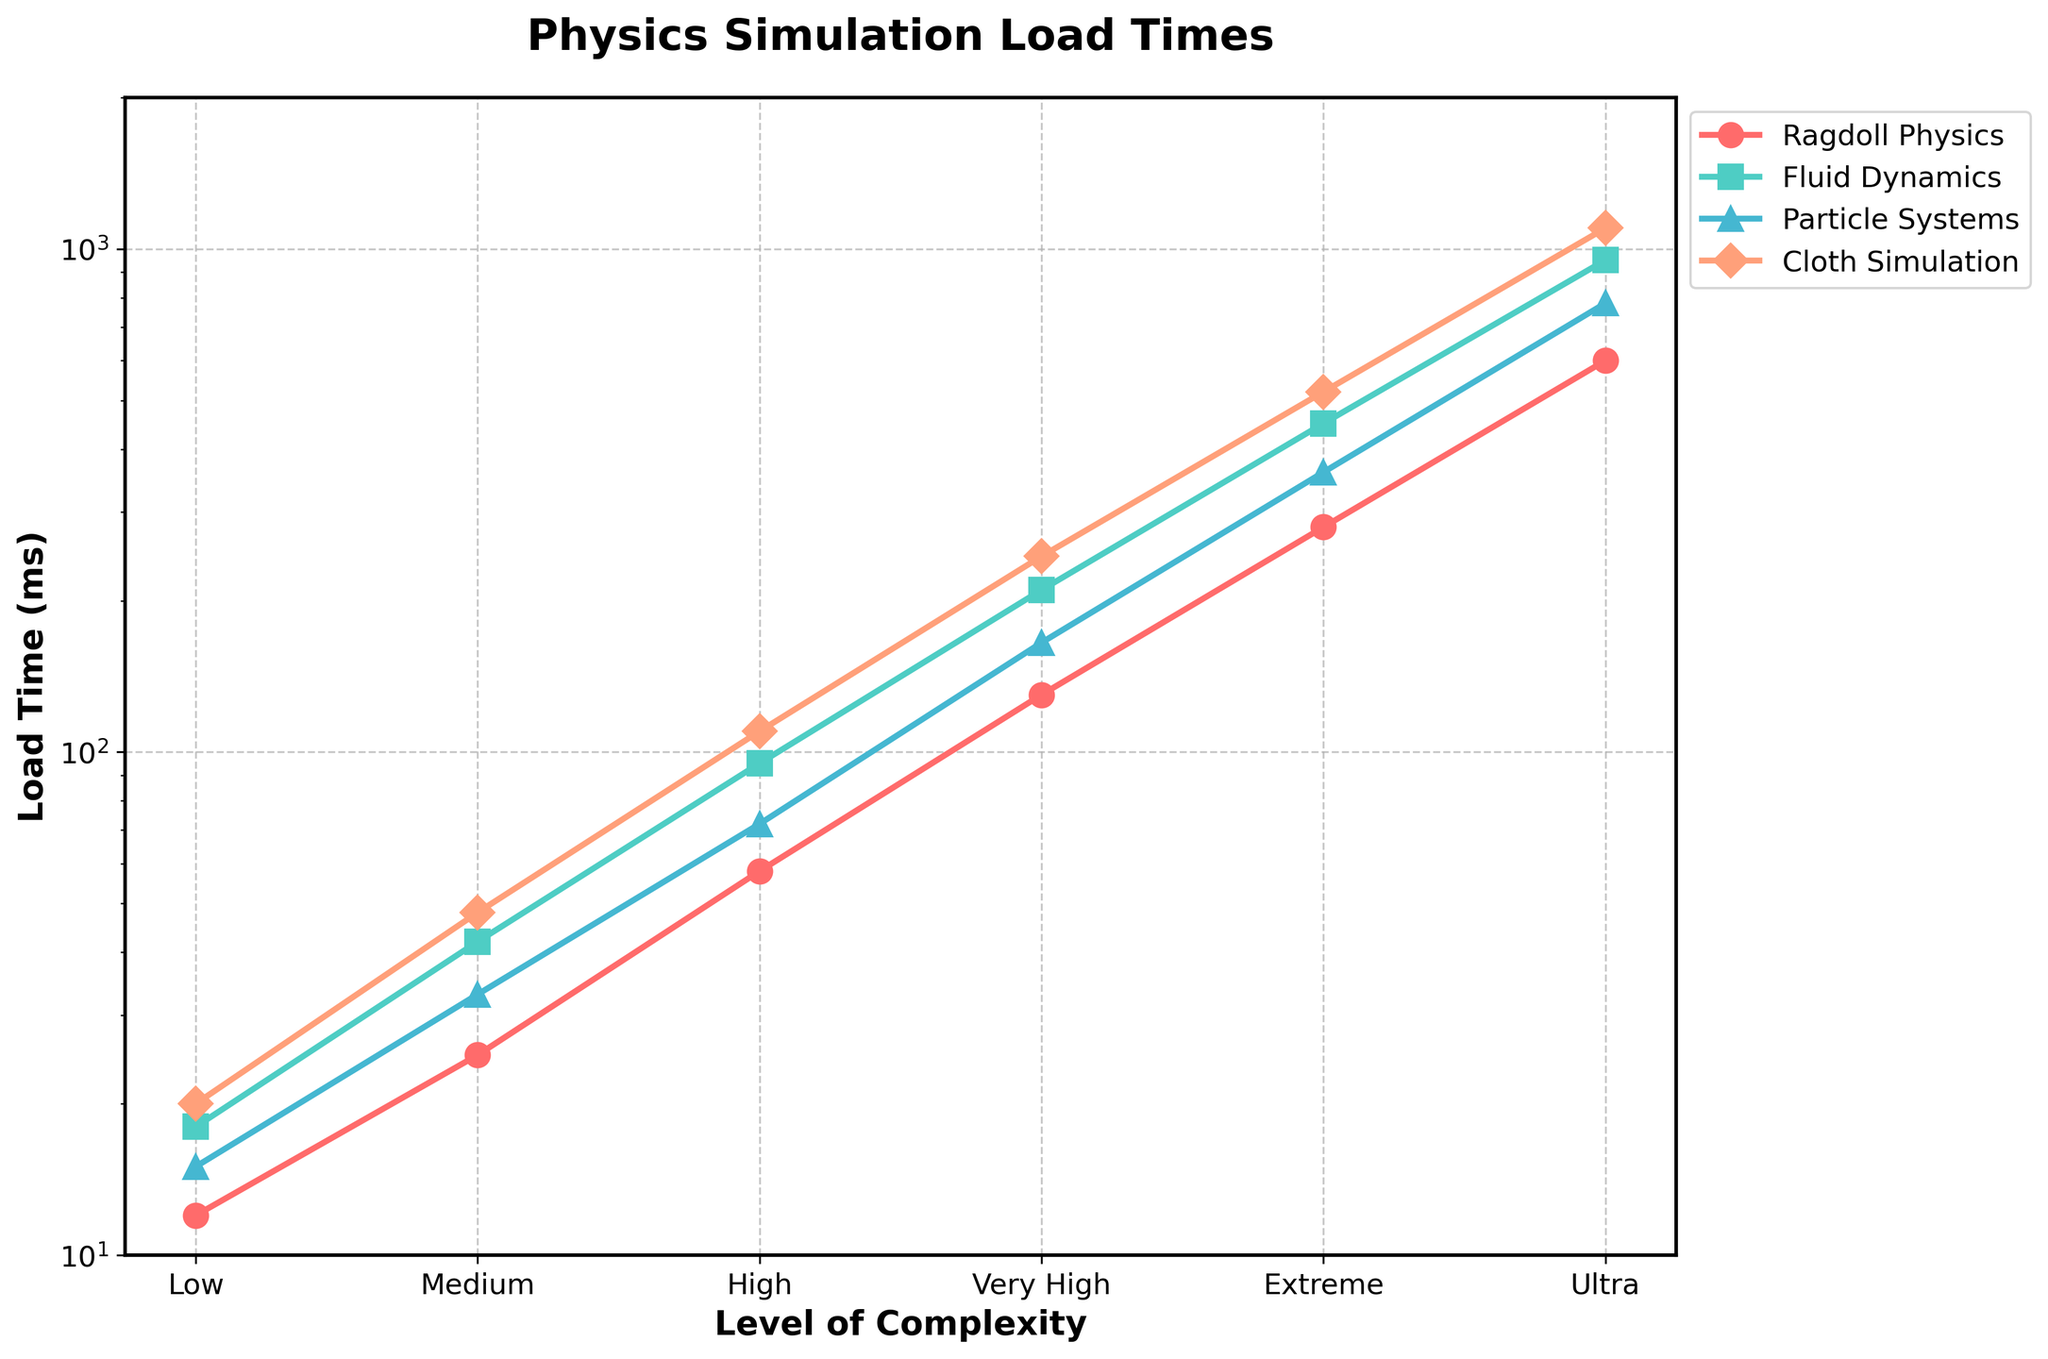What is the load time for Fluid Dynamics at the High complexity level? Look for the data point where Fluid Dynamics intersects with High complexity. Fluid Dynamics at High complexity is marked by a green line with triangle markers. The value reads 95 ms.
Answer: 95 ms How many times greater is the load time for Ragdoll Physics at Ultra complexity compared to Medium complexity? Identify the load times for Ragdoll Physics at Ultra and Medium complexity levels, which are represented by the red line with circle markers. From the plot, Medium complexity has a load time of 25 ms, and Ultra complexity has a load time of 600 ms. Calculate the ratio: 600 ms / 25 ms = 24.
Answer: 24 Which simulation has the highest load time at Very High complexity? Examine the data point at the Very High complexity level for all simulation types. Identify which peak is the highest. The pink line with diamond markers for Cloth Simulation records the highest load time at 245 ms.
Answer: Cloth Simulation What is the difference in load time between Particle Systems and Cloth Simulation at Extreme complexity? Find and compare the data points for Particle Systems and Cloth Simulation at Extreme complexity. Particle Systems (blue marker with triangle) has a load time of 360 ms, while Cloth Simulation (pink diamond marker) has 520 ms. The difference is 520 ms - 360 ms = 160 ms.
Answer: 160 ms What is the load time trend for Ragdoll Physics as the level of complexity increases? Observe the red line with circle markers for Ragdoll Physics as complexity progresses from Low to Ultra levels. The line rises steeply, indicating an exponential increase in load time.
Answer: Exponential Increase Does Fluid Dynamics ever have the lowest load time at any complexity level? Check each level of complexity and compare the load times among the four physics simulations. Fluid Dynamics, represented by a green line with square markers, is never the lowest at any complexity level.
Answer: No How does the increase in load time from High to Very High complexity for Cloth Simulation compare to that of Ragdoll Physics? Identify the load times for both simulations at High and Very High complex levels. Cloth Simulation: 110 ms to 245 ms (an increase of 135 ms). Ragdoll Physics: 58 ms to 130 ms (an increase of 72 ms). Thus, Cloth Simulation increases more by 135 ms - 72 ms = 63 ms.
Answer: Cloth Simulation increases by 63 ms more What's the average load time for Particle Systems across all complexity levels? Add the load times for Particle Systems at each complexity level: 15 ms + 33 ms + 72 ms + 165 ms + 360 ms + 780 ms = 1425 ms. Divide by the number of levels (6) to get the average: 1425 ms / 6 = 237.5 ms.
Answer: 237.5 ms 